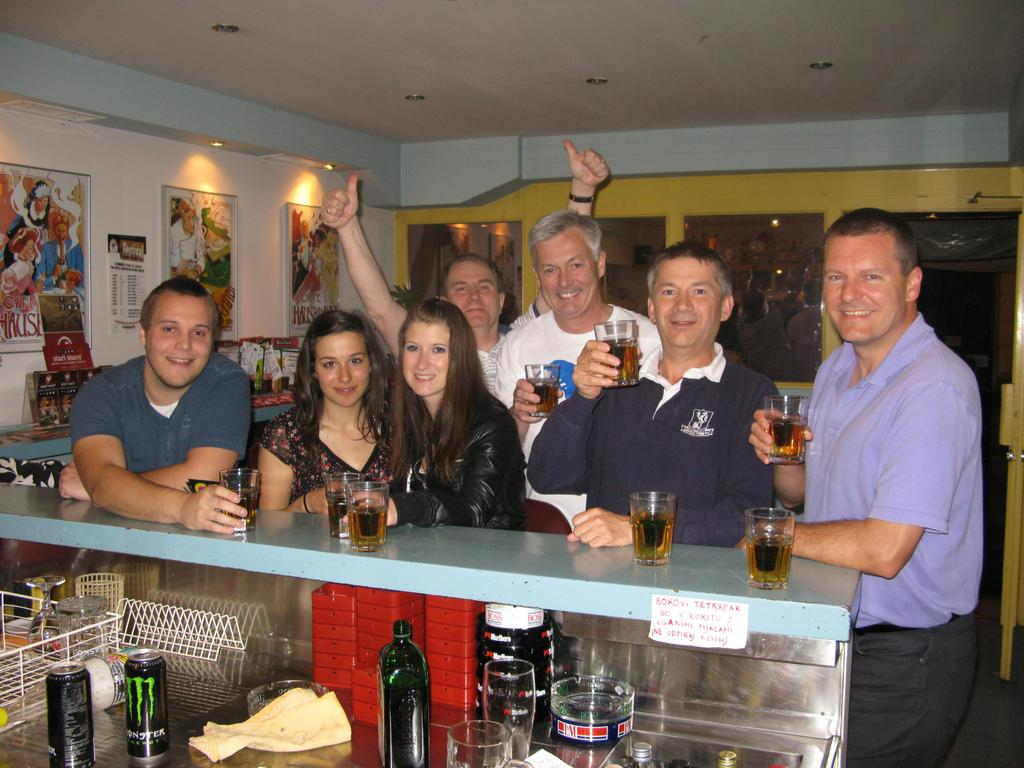How many people are in the image? There is a group of persons in the image. What are the persons doing in the image? The persons are standing in front of a table. What objects are the persons holding in the image? The persons are holding glasses. Can you describe any decorative elements in the image? There is a photo frame on the wall in the image. Where is the toothpaste located in the image? There is no toothpaste present in the image. What type of badge is being worn by the persons in the image? There is no badge visible in the image. 